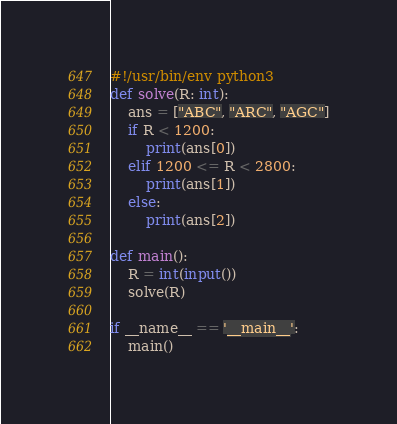<code> <loc_0><loc_0><loc_500><loc_500><_Python_>#!/usr/bin/env python3
def solve(R: int):
    ans = ["ABC", "ARC", "AGC"]
    if R < 1200:
        print(ans[0])
    elif 1200 <= R < 2800:
        print(ans[1])
    else:
        print(ans[2])

def main():
    R = int(input())
    solve(R)

if __name__ == '__main__':
    main()
</code> 